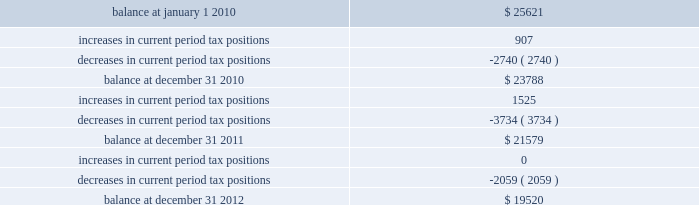The table summarizes the changes in the company 2019s valuation allowance: .
Note 14 : employee benefits pension and other postretirement benefits the company maintains noncontributory defined benefit pension plans covering eligible employees of its regulated utility and shared services operations .
Benefits under the plans are based on the employee 2019s years of service and compensation .
The pension plans have been closed for most employees hired on or after january 1 , 2006 .
Union employees hired on or after january 1 , 2001 had their accrued benefit frozen and will be able to receive this benefit as a lump sum upon termination or retirement .
Union employees hired on or after january 1 , 2001 and non-union employees hired on or after january 1 , 2006 are provided with a 5.25% ( 5.25 % ) of base pay defined contribution plan .
The company does not participate in a multiemployer plan .
The company 2019s funding policy is to contribute at least the greater of the minimum amount required by the employee retirement income security act of 1974 or the normal cost , and an additional contribution if needed to avoid 201cat risk 201d status and benefit restrictions under the pension protection act of 2006 .
The company may also increase its contributions , if appropriate , to its tax and cash position and the plan 2019s funded position .
Pension plan assets are invested in a number of actively managed and indexed investments including equity and bond mutual funds , fixed income securities and guaranteed interest contracts with insurance companies .
Pension expense in excess of the amount contributed to the pension plans is deferred by certain regulated subsidiaries pending future recovery in rates charged for utility services as contributions are made to the plans .
( see note 6 ) the company also has several unfunded noncontributory supplemental non-qualified pension plans that provide additional retirement benefits to certain employees .
The company maintains other postretirement benefit plans providing varying levels of medical and life insurance to eligible retirees .
The retiree welfare plans are closed for union employees hired on or after january 1 , 2006 .
The plans had previously closed for non-union employees hired on or after january 1 , 2002 .
The company 2019s policy is to fund other postretirement benefit costs for rate-making purposes .
Plan assets are invested in equity and bond mutual funds , fixed income securities , real estate investment trusts ( 201creits 201d ) and emerging market funds .
The obligations of the plans are dominated by obligations for active employees .
Because the timing of expected benefit payments is so far in the future and the size of the plan assets are small relative to the company 2019s assets , the investment strategy is to allocate a significant percentage of assets to equities , which the company believes will provide the highest return over the long-term period .
The fixed income assets are invested in long duration debt securities and may be invested in fixed income instruments , such as futures and options in order to better match the duration of the plan liability. .
What was the net change in tax positions in 2010? 
Rationale: the net tax position is the sum of the increase and the decrease to determine whether the overall change was favorable or not
Computations: (907 + -2740)
Answer: -1833.0. 